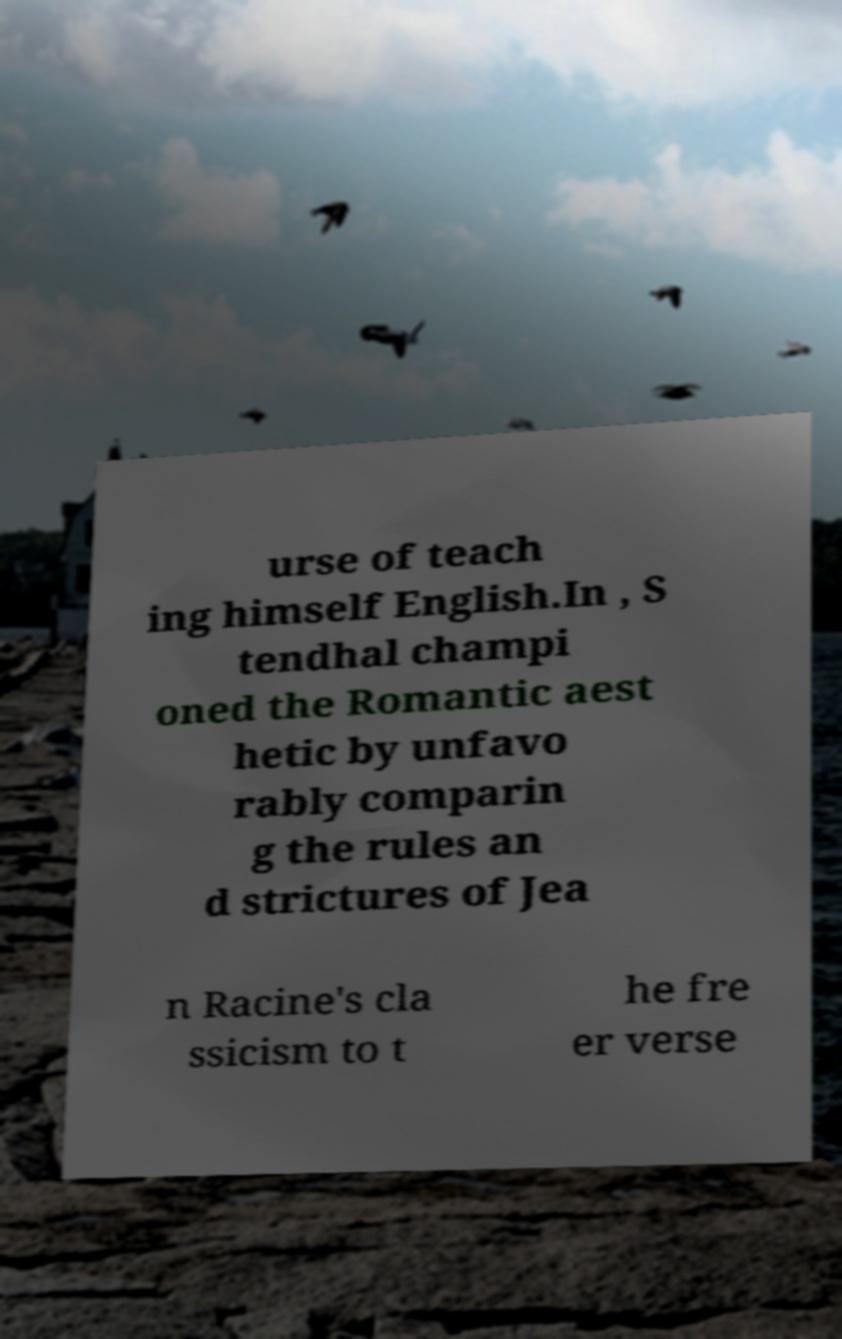Can you read and provide the text displayed in the image?This photo seems to have some interesting text. Can you extract and type it out for me? urse of teach ing himself English.In , S tendhal champi oned the Romantic aest hetic by unfavo rably comparin g the rules an d strictures of Jea n Racine's cla ssicism to t he fre er verse 